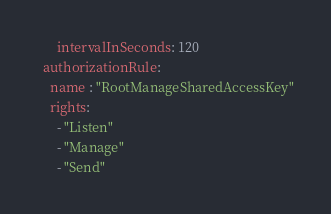<code> <loc_0><loc_0><loc_500><loc_500><_YAML_>      intervalInSeconds: 120
  authorizationRule: 
    name : "RootManageSharedAccessKey"
    rights: 
      - "Listen"
      - "Manage"
      - "Send"
</code> 